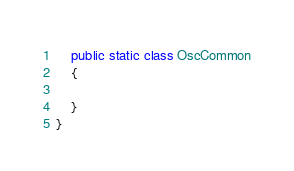<code> <loc_0><loc_0><loc_500><loc_500><_C#_>    public static class OscCommon
    {

    }
}</code> 